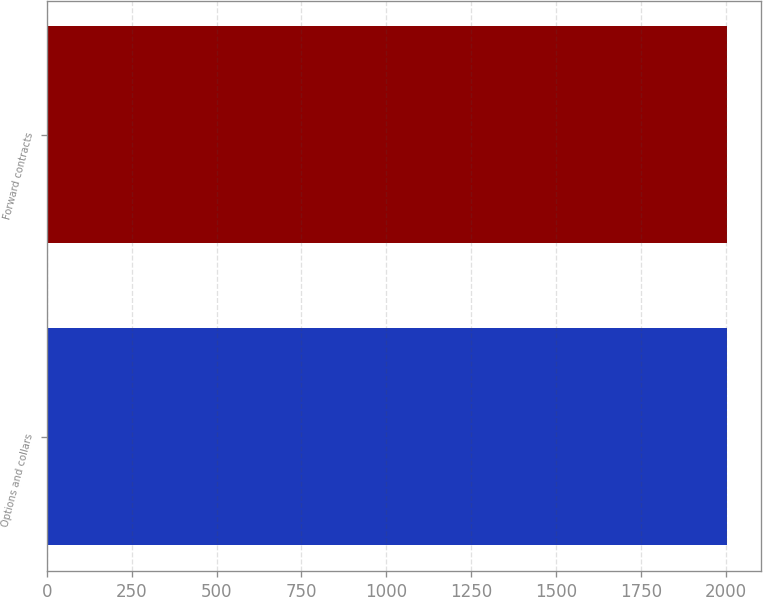<chart> <loc_0><loc_0><loc_500><loc_500><bar_chart><fcel>Options and collars<fcel>Forward contracts<nl><fcel>2004<fcel>2003<nl></chart> 